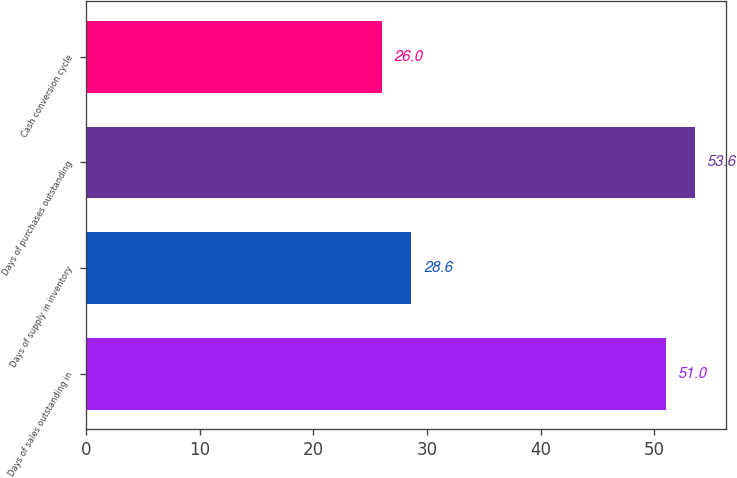<chart> <loc_0><loc_0><loc_500><loc_500><bar_chart><fcel>Days of sales outstanding in<fcel>Days of supply in inventory<fcel>Days of purchases outstanding<fcel>Cash conversion cycle<nl><fcel>51<fcel>28.6<fcel>53.6<fcel>26<nl></chart> 